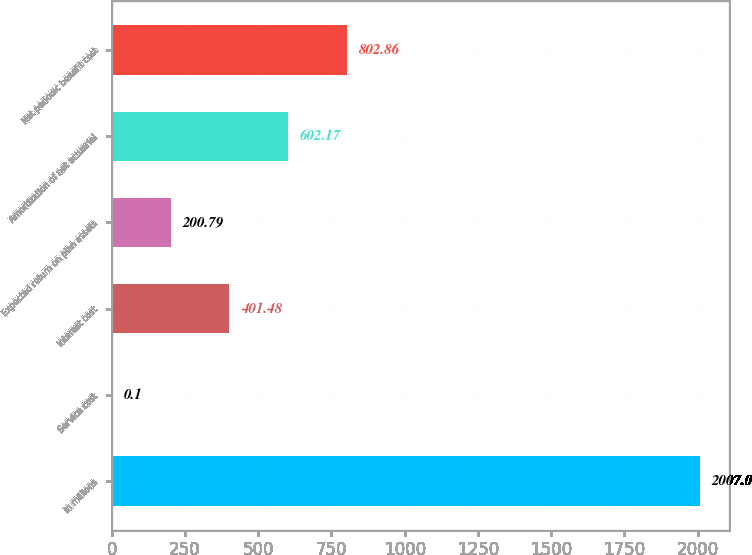<chart> <loc_0><loc_0><loc_500><loc_500><bar_chart><fcel>in millions<fcel>Service cost<fcel>Interest cost<fcel>Expected return on plan assets<fcel>Amortization of net actuarial<fcel>Net periodic benefit cost<nl><fcel>2007<fcel>0.1<fcel>401.48<fcel>200.79<fcel>602.17<fcel>802.86<nl></chart> 